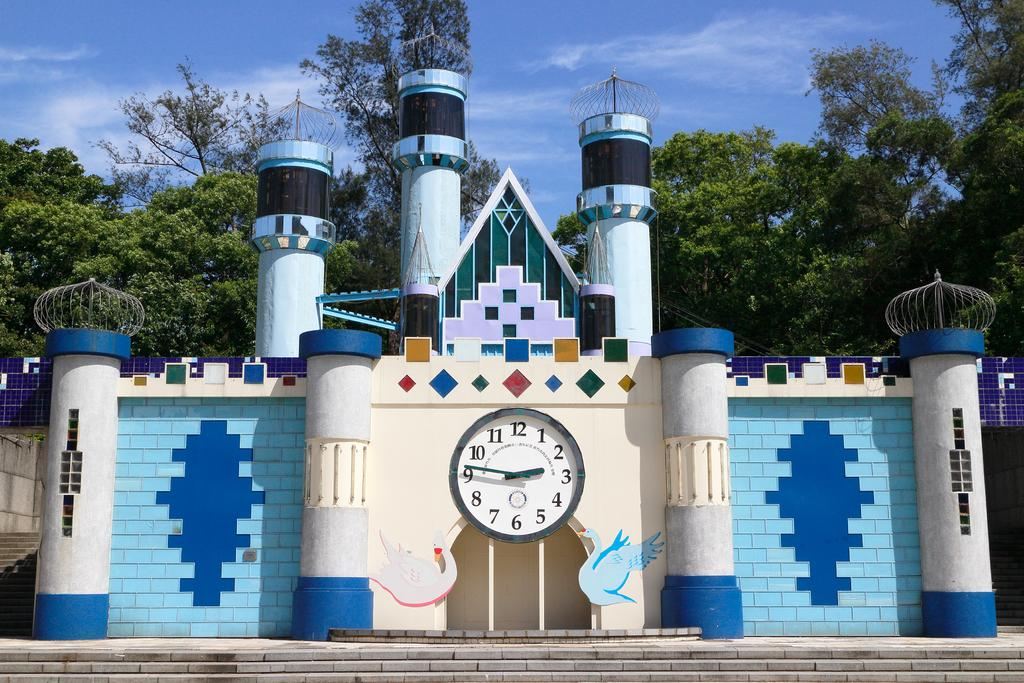<image>
Relay a brief, clear account of the picture shown. A colorful brick castle building with a large analog clock at center with the numbers 1-12 on the clock. 